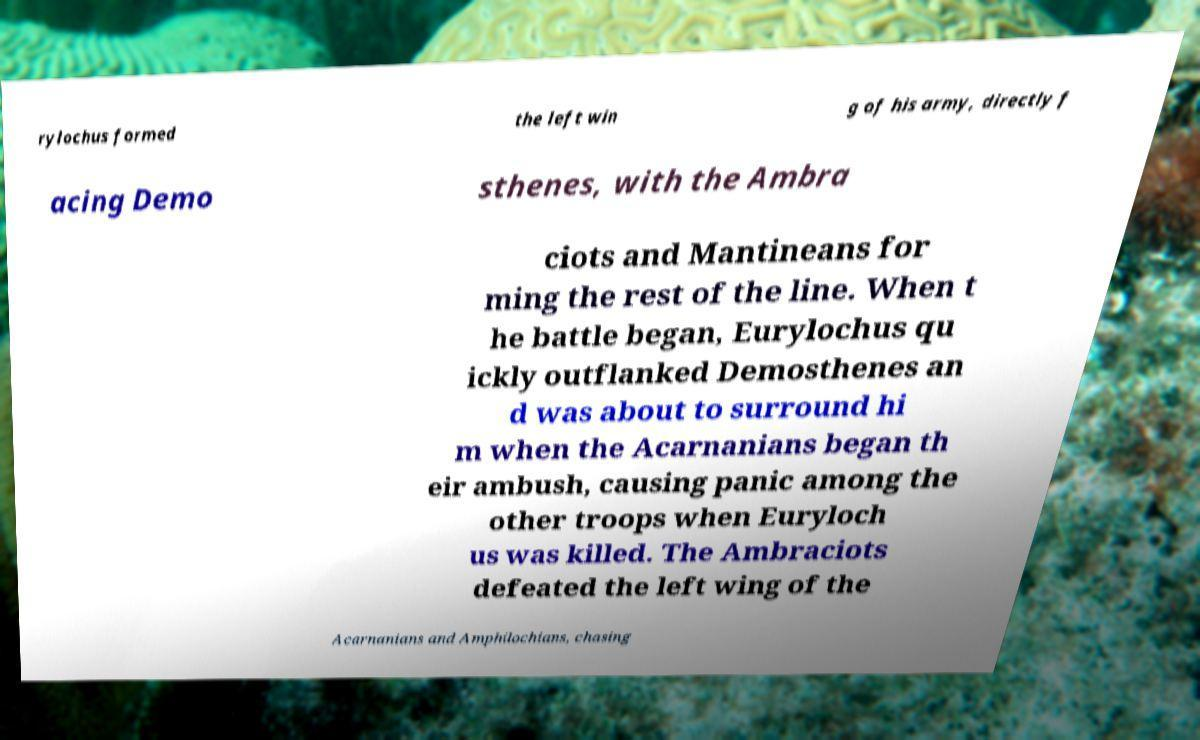Please read and relay the text visible in this image. What does it say? rylochus formed the left win g of his army, directly f acing Demo sthenes, with the Ambra ciots and Mantineans for ming the rest of the line. When t he battle began, Eurylochus qu ickly outflanked Demosthenes an d was about to surround hi m when the Acarnanians began th eir ambush, causing panic among the other troops when Euryloch us was killed. The Ambraciots defeated the left wing of the Acarnanians and Amphilochians, chasing 